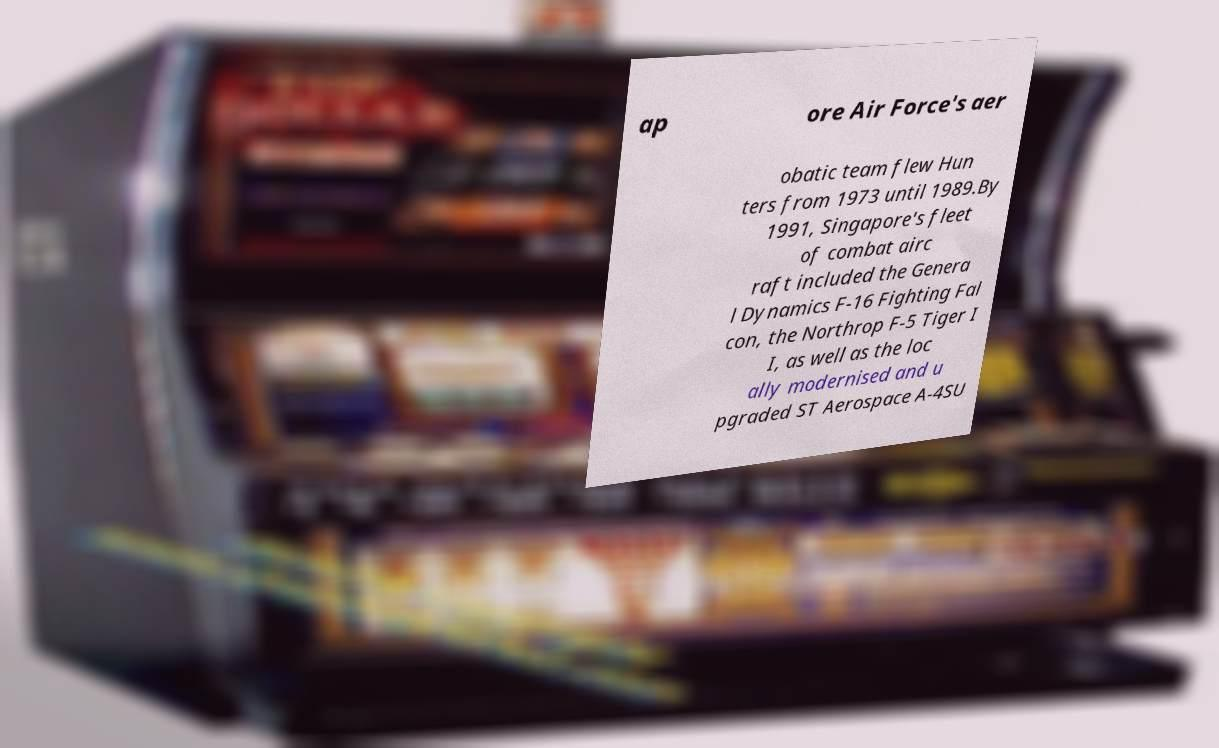Please identify and transcribe the text found in this image. ap ore Air Force's aer obatic team flew Hun ters from 1973 until 1989.By 1991, Singapore's fleet of combat airc raft included the Genera l Dynamics F-16 Fighting Fal con, the Northrop F-5 Tiger I I, as well as the loc ally modernised and u pgraded ST Aerospace A-4SU 